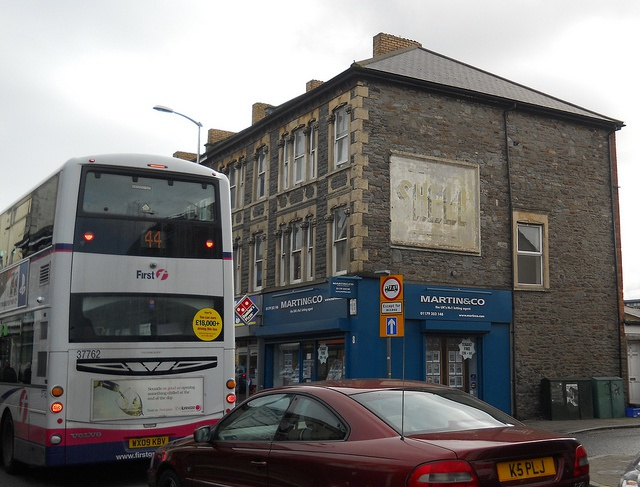Describe the objects in this image and their specific colors. I can see bus in lightgray, black, gray, and maroon tones, car in lightgray, black, gray, maroon, and darkgray tones, and car in lightgray, gray, and darkgray tones in this image. 